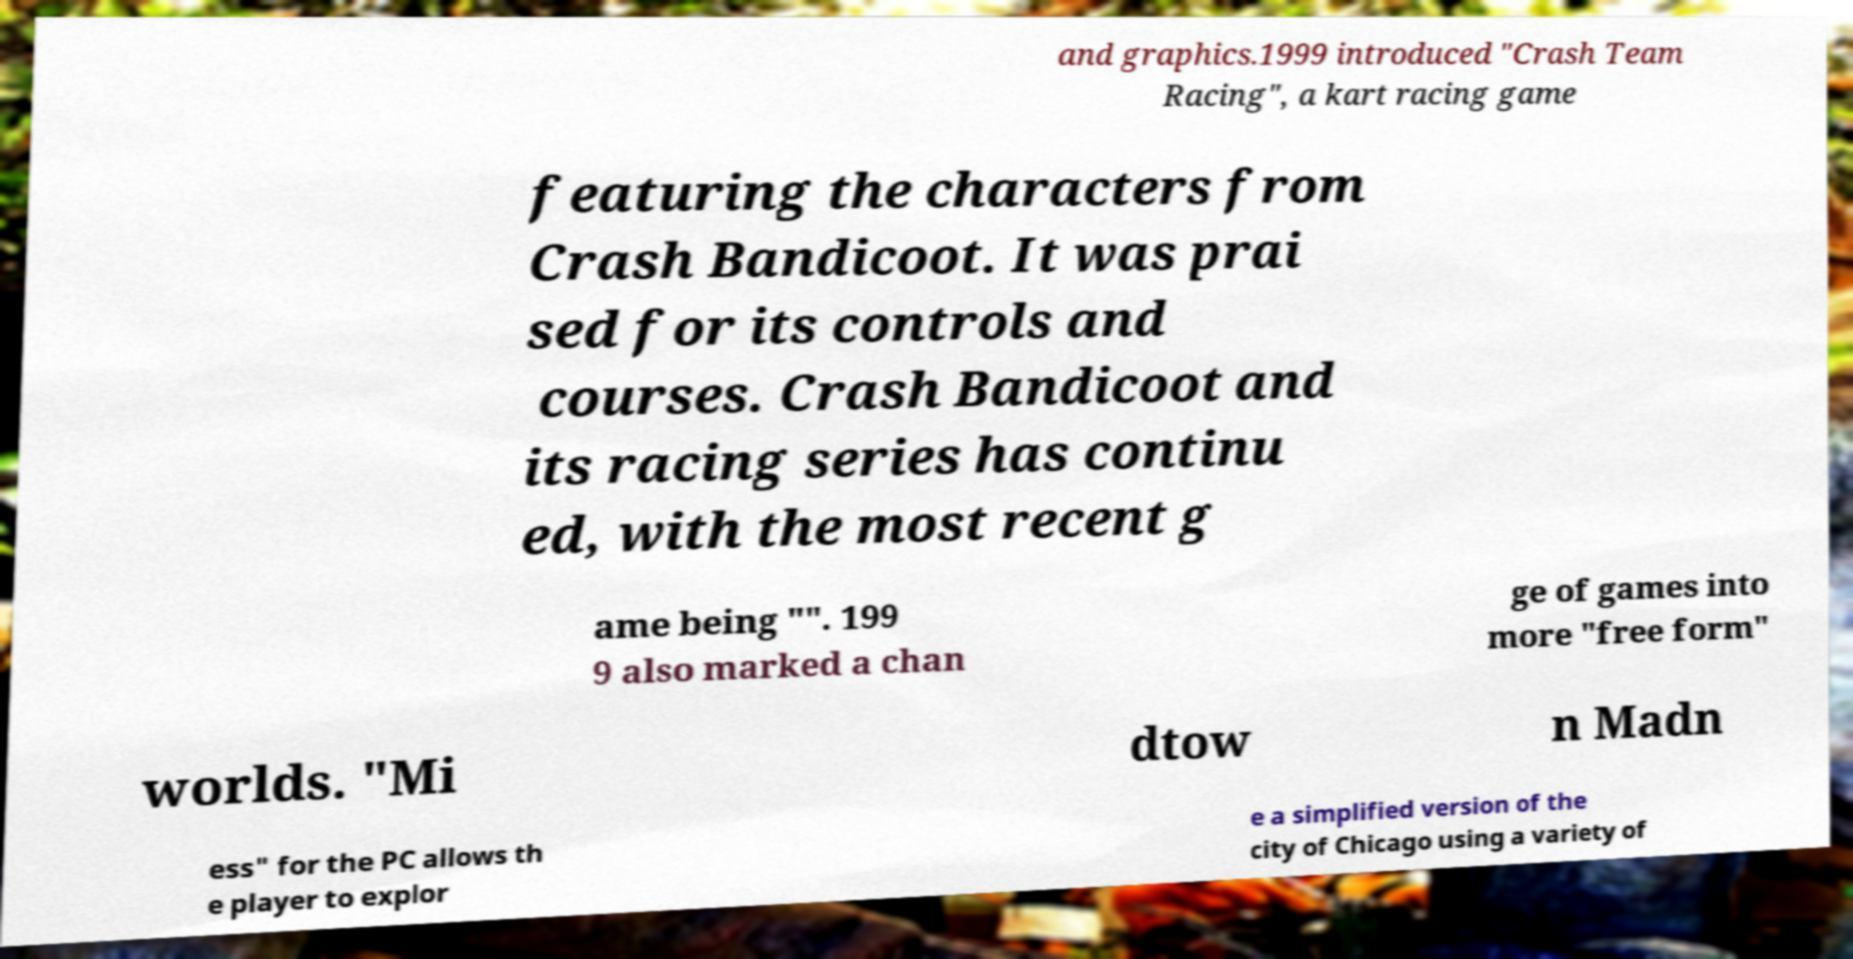Could you extract and type out the text from this image? and graphics.1999 introduced "Crash Team Racing", a kart racing game featuring the characters from Crash Bandicoot. It was prai sed for its controls and courses. Crash Bandicoot and its racing series has continu ed, with the most recent g ame being "". 199 9 also marked a chan ge of games into more "free form" worlds. "Mi dtow n Madn ess" for the PC allows th e player to explor e a simplified version of the city of Chicago using a variety of 